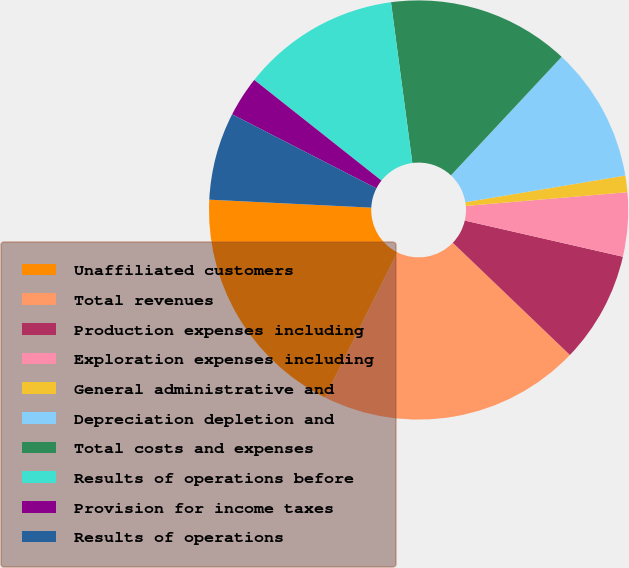Convert chart to OTSL. <chart><loc_0><loc_0><loc_500><loc_500><pie_chart><fcel>Unaffiliated customers<fcel>Total revenues<fcel>Production expenses including<fcel>Exploration expenses including<fcel>General administrative and<fcel>Depreciation depletion and<fcel>Total costs and expenses<fcel>Results of operations before<fcel>Provision for income taxes<fcel>Results of operations<nl><fcel>18.4%<fcel>20.22%<fcel>8.58%<fcel>4.93%<fcel>1.28%<fcel>10.41%<fcel>14.06%<fcel>12.24%<fcel>3.11%<fcel>6.76%<nl></chart> 